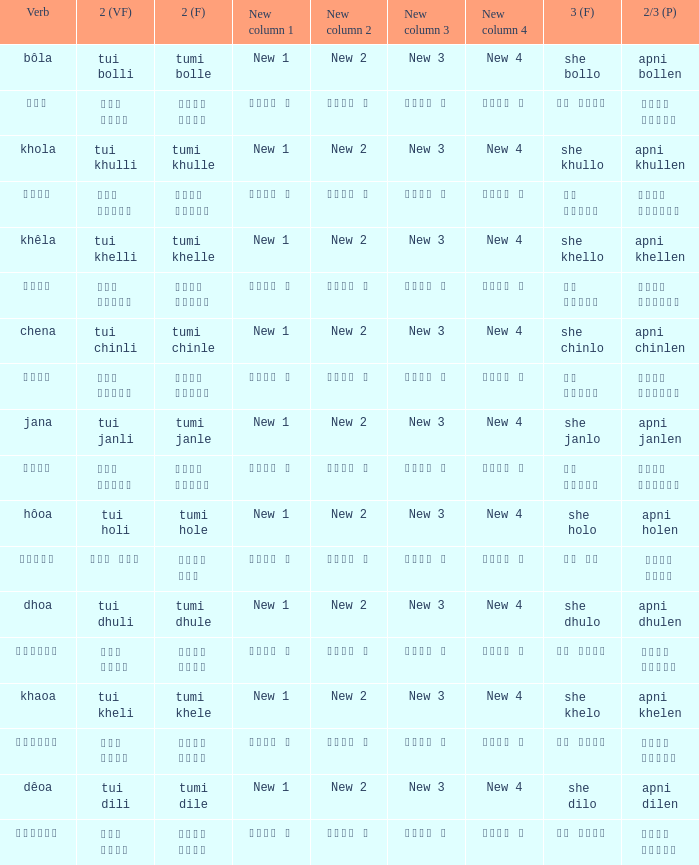What is the 2nd verb for chena? Tumi chinle. 